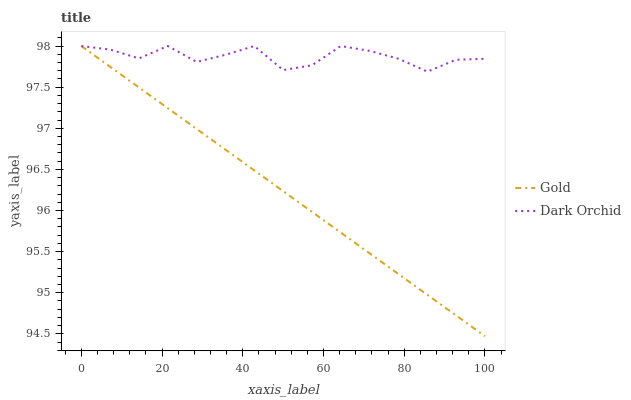Does Gold have the minimum area under the curve?
Answer yes or no. Yes. Does Dark Orchid have the maximum area under the curve?
Answer yes or no. Yes. Does Gold have the maximum area under the curve?
Answer yes or no. No. Is Gold the smoothest?
Answer yes or no. Yes. Is Dark Orchid the roughest?
Answer yes or no. Yes. Is Gold the roughest?
Answer yes or no. No. Does Gold have the highest value?
Answer yes or no. Yes. 